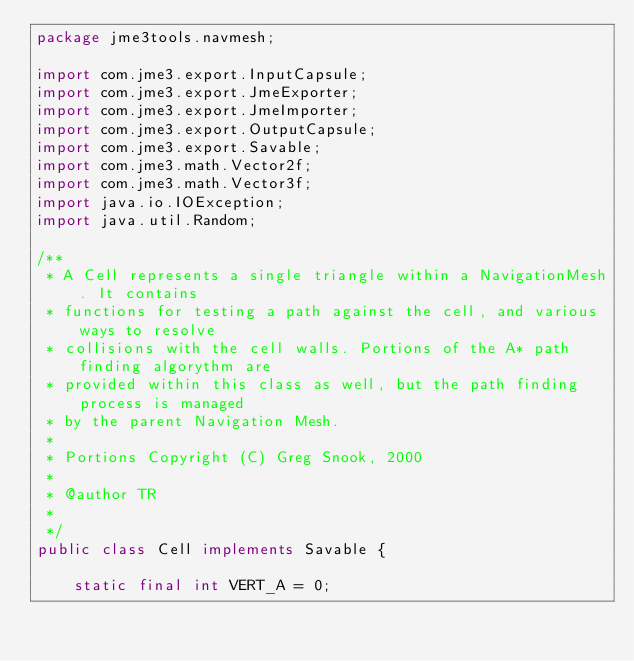Convert code to text. <code><loc_0><loc_0><loc_500><loc_500><_Java_>package jme3tools.navmesh;

import com.jme3.export.InputCapsule;
import com.jme3.export.JmeExporter;
import com.jme3.export.JmeImporter;
import com.jme3.export.OutputCapsule;
import com.jme3.export.Savable;
import com.jme3.math.Vector2f;
import com.jme3.math.Vector3f;
import java.io.IOException;
import java.util.Random;

/**
 * A Cell represents a single triangle within a NavigationMesh. It contains
 * functions for testing a path against the cell, and various ways to resolve
 * collisions with the cell walls. Portions of the A* path finding algorythm are
 * provided within this class as well, but the path finding process is managed
 * by the parent Navigation Mesh.
 * 
 * Portions Copyright (C) Greg Snook, 2000
 * 
 * @author TR
 * 
 */
public class Cell implements Savable {

    static final int VERT_A = 0;</code> 